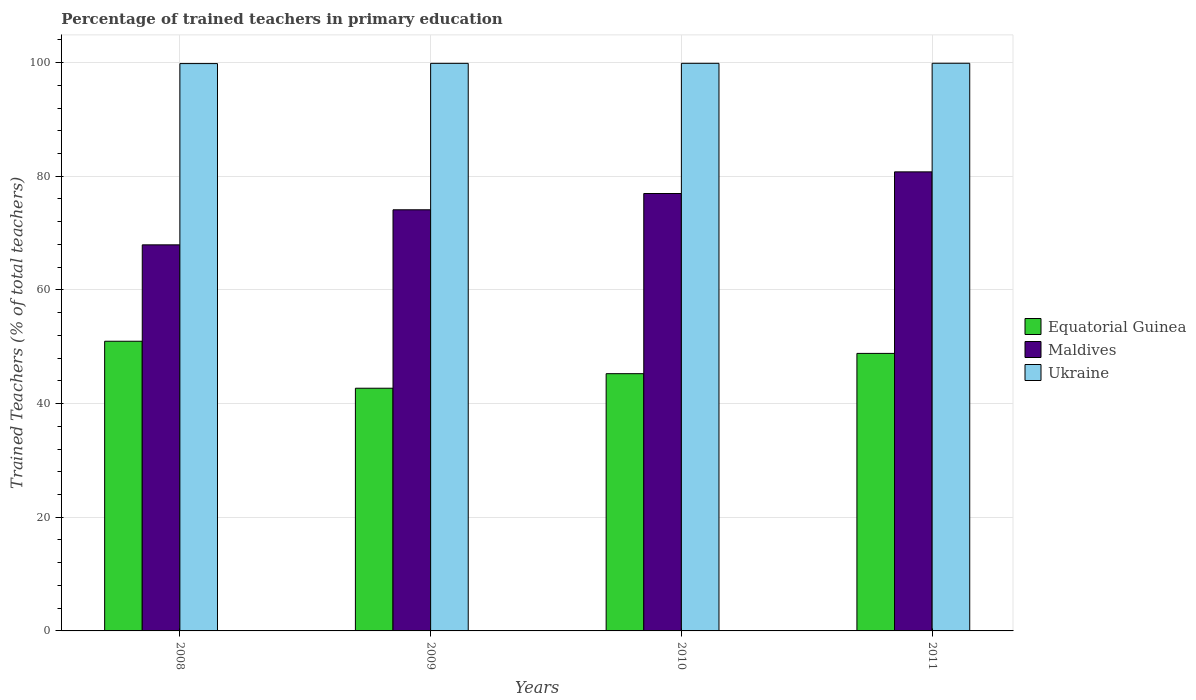How many groups of bars are there?
Offer a very short reply. 4. Are the number of bars per tick equal to the number of legend labels?
Provide a short and direct response. Yes. Are the number of bars on each tick of the X-axis equal?
Provide a succinct answer. Yes. How many bars are there on the 3rd tick from the right?
Ensure brevity in your answer.  3. In how many cases, is the number of bars for a given year not equal to the number of legend labels?
Your answer should be compact. 0. What is the percentage of trained teachers in Ukraine in 2009?
Offer a very short reply. 99.86. Across all years, what is the maximum percentage of trained teachers in Maldives?
Your response must be concise. 80.76. Across all years, what is the minimum percentage of trained teachers in Equatorial Guinea?
Your response must be concise. 42.7. In which year was the percentage of trained teachers in Ukraine minimum?
Provide a succinct answer. 2008. What is the total percentage of trained teachers in Maldives in the graph?
Keep it short and to the point. 299.74. What is the difference between the percentage of trained teachers in Maldives in 2008 and that in 2009?
Your response must be concise. -6.17. What is the difference between the percentage of trained teachers in Ukraine in 2008 and the percentage of trained teachers in Equatorial Guinea in 2010?
Your response must be concise. 54.56. What is the average percentage of trained teachers in Ukraine per year?
Your response must be concise. 99.85. In the year 2010, what is the difference between the percentage of trained teachers in Ukraine and percentage of trained teachers in Maldives?
Make the answer very short. 22.91. What is the ratio of the percentage of trained teachers in Maldives in 2009 to that in 2010?
Provide a succinct answer. 0.96. Is the percentage of trained teachers in Equatorial Guinea in 2008 less than that in 2009?
Your answer should be compact. No. Is the difference between the percentage of trained teachers in Ukraine in 2009 and 2010 greater than the difference between the percentage of trained teachers in Maldives in 2009 and 2010?
Ensure brevity in your answer.  Yes. What is the difference between the highest and the second highest percentage of trained teachers in Maldives?
Your answer should be very brief. 3.81. What is the difference between the highest and the lowest percentage of trained teachers in Equatorial Guinea?
Make the answer very short. 8.27. In how many years, is the percentage of trained teachers in Maldives greater than the average percentage of trained teachers in Maldives taken over all years?
Offer a very short reply. 2. Is the sum of the percentage of trained teachers in Equatorial Guinea in 2008 and 2009 greater than the maximum percentage of trained teachers in Maldives across all years?
Ensure brevity in your answer.  Yes. What does the 3rd bar from the left in 2008 represents?
Offer a very short reply. Ukraine. What does the 3rd bar from the right in 2009 represents?
Keep it short and to the point. Equatorial Guinea. Is it the case that in every year, the sum of the percentage of trained teachers in Ukraine and percentage of trained teachers in Equatorial Guinea is greater than the percentage of trained teachers in Maldives?
Offer a very short reply. Yes. How many bars are there?
Keep it short and to the point. 12. Does the graph contain any zero values?
Give a very brief answer. No. Does the graph contain grids?
Ensure brevity in your answer.  Yes. How many legend labels are there?
Offer a terse response. 3. How are the legend labels stacked?
Offer a terse response. Vertical. What is the title of the graph?
Offer a terse response. Percentage of trained teachers in primary education. What is the label or title of the X-axis?
Your response must be concise. Years. What is the label or title of the Y-axis?
Keep it short and to the point. Trained Teachers (% of total teachers). What is the Trained Teachers (% of total teachers) in Equatorial Guinea in 2008?
Your answer should be very brief. 50.97. What is the Trained Teachers (% of total teachers) in Maldives in 2008?
Your answer should be compact. 67.92. What is the Trained Teachers (% of total teachers) of Ukraine in 2008?
Your response must be concise. 99.82. What is the Trained Teachers (% of total teachers) in Equatorial Guinea in 2009?
Your answer should be very brief. 42.7. What is the Trained Teachers (% of total teachers) in Maldives in 2009?
Your answer should be very brief. 74.09. What is the Trained Teachers (% of total teachers) of Ukraine in 2009?
Make the answer very short. 99.86. What is the Trained Teachers (% of total teachers) of Equatorial Guinea in 2010?
Make the answer very short. 45.26. What is the Trained Teachers (% of total teachers) of Maldives in 2010?
Your answer should be compact. 76.96. What is the Trained Teachers (% of total teachers) in Ukraine in 2010?
Your answer should be compact. 99.86. What is the Trained Teachers (% of total teachers) in Equatorial Guinea in 2011?
Your answer should be very brief. 48.83. What is the Trained Teachers (% of total teachers) of Maldives in 2011?
Ensure brevity in your answer.  80.76. What is the Trained Teachers (% of total teachers) in Ukraine in 2011?
Provide a succinct answer. 99.87. Across all years, what is the maximum Trained Teachers (% of total teachers) in Equatorial Guinea?
Provide a short and direct response. 50.97. Across all years, what is the maximum Trained Teachers (% of total teachers) of Maldives?
Ensure brevity in your answer.  80.76. Across all years, what is the maximum Trained Teachers (% of total teachers) in Ukraine?
Keep it short and to the point. 99.87. Across all years, what is the minimum Trained Teachers (% of total teachers) of Equatorial Guinea?
Your answer should be very brief. 42.7. Across all years, what is the minimum Trained Teachers (% of total teachers) of Maldives?
Offer a very short reply. 67.92. Across all years, what is the minimum Trained Teachers (% of total teachers) of Ukraine?
Provide a short and direct response. 99.82. What is the total Trained Teachers (% of total teachers) of Equatorial Guinea in the graph?
Provide a short and direct response. 187.75. What is the total Trained Teachers (% of total teachers) of Maldives in the graph?
Provide a succinct answer. 299.74. What is the total Trained Teachers (% of total teachers) of Ukraine in the graph?
Provide a succinct answer. 399.41. What is the difference between the Trained Teachers (% of total teachers) of Equatorial Guinea in 2008 and that in 2009?
Your response must be concise. 8.27. What is the difference between the Trained Teachers (% of total teachers) of Maldives in 2008 and that in 2009?
Offer a very short reply. -6.17. What is the difference between the Trained Teachers (% of total teachers) in Ukraine in 2008 and that in 2009?
Provide a short and direct response. -0.04. What is the difference between the Trained Teachers (% of total teachers) in Equatorial Guinea in 2008 and that in 2010?
Offer a terse response. 5.71. What is the difference between the Trained Teachers (% of total teachers) of Maldives in 2008 and that in 2010?
Ensure brevity in your answer.  -9.03. What is the difference between the Trained Teachers (% of total teachers) in Ukraine in 2008 and that in 2010?
Give a very brief answer. -0.05. What is the difference between the Trained Teachers (% of total teachers) in Equatorial Guinea in 2008 and that in 2011?
Keep it short and to the point. 2.14. What is the difference between the Trained Teachers (% of total teachers) of Maldives in 2008 and that in 2011?
Give a very brief answer. -12.84. What is the difference between the Trained Teachers (% of total teachers) of Ukraine in 2008 and that in 2011?
Ensure brevity in your answer.  -0.06. What is the difference between the Trained Teachers (% of total teachers) of Equatorial Guinea in 2009 and that in 2010?
Ensure brevity in your answer.  -2.56. What is the difference between the Trained Teachers (% of total teachers) in Maldives in 2009 and that in 2010?
Provide a succinct answer. -2.87. What is the difference between the Trained Teachers (% of total teachers) of Ukraine in 2009 and that in 2010?
Make the answer very short. -0.01. What is the difference between the Trained Teachers (% of total teachers) in Equatorial Guinea in 2009 and that in 2011?
Offer a very short reply. -6.13. What is the difference between the Trained Teachers (% of total teachers) in Maldives in 2009 and that in 2011?
Provide a succinct answer. -6.67. What is the difference between the Trained Teachers (% of total teachers) of Ukraine in 2009 and that in 2011?
Provide a short and direct response. -0.02. What is the difference between the Trained Teachers (% of total teachers) of Equatorial Guinea in 2010 and that in 2011?
Your answer should be very brief. -3.57. What is the difference between the Trained Teachers (% of total teachers) of Maldives in 2010 and that in 2011?
Ensure brevity in your answer.  -3.81. What is the difference between the Trained Teachers (% of total teachers) of Ukraine in 2010 and that in 2011?
Give a very brief answer. -0.01. What is the difference between the Trained Teachers (% of total teachers) of Equatorial Guinea in 2008 and the Trained Teachers (% of total teachers) of Maldives in 2009?
Offer a terse response. -23.13. What is the difference between the Trained Teachers (% of total teachers) in Equatorial Guinea in 2008 and the Trained Teachers (% of total teachers) in Ukraine in 2009?
Your response must be concise. -48.89. What is the difference between the Trained Teachers (% of total teachers) in Maldives in 2008 and the Trained Teachers (% of total teachers) in Ukraine in 2009?
Ensure brevity in your answer.  -31.93. What is the difference between the Trained Teachers (% of total teachers) in Equatorial Guinea in 2008 and the Trained Teachers (% of total teachers) in Maldives in 2010?
Give a very brief answer. -25.99. What is the difference between the Trained Teachers (% of total teachers) in Equatorial Guinea in 2008 and the Trained Teachers (% of total teachers) in Ukraine in 2010?
Provide a short and direct response. -48.9. What is the difference between the Trained Teachers (% of total teachers) of Maldives in 2008 and the Trained Teachers (% of total teachers) of Ukraine in 2010?
Provide a succinct answer. -31.94. What is the difference between the Trained Teachers (% of total teachers) of Equatorial Guinea in 2008 and the Trained Teachers (% of total teachers) of Maldives in 2011?
Ensure brevity in your answer.  -29.8. What is the difference between the Trained Teachers (% of total teachers) in Equatorial Guinea in 2008 and the Trained Teachers (% of total teachers) in Ukraine in 2011?
Ensure brevity in your answer.  -48.91. What is the difference between the Trained Teachers (% of total teachers) in Maldives in 2008 and the Trained Teachers (% of total teachers) in Ukraine in 2011?
Your answer should be compact. -31.95. What is the difference between the Trained Teachers (% of total teachers) in Equatorial Guinea in 2009 and the Trained Teachers (% of total teachers) in Maldives in 2010?
Ensure brevity in your answer.  -34.26. What is the difference between the Trained Teachers (% of total teachers) in Equatorial Guinea in 2009 and the Trained Teachers (% of total teachers) in Ukraine in 2010?
Your answer should be compact. -57.17. What is the difference between the Trained Teachers (% of total teachers) of Maldives in 2009 and the Trained Teachers (% of total teachers) of Ukraine in 2010?
Provide a short and direct response. -25.77. What is the difference between the Trained Teachers (% of total teachers) in Equatorial Guinea in 2009 and the Trained Teachers (% of total teachers) in Maldives in 2011?
Your answer should be very brief. -38.07. What is the difference between the Trained Teachers (% of total teachers) of Equatorial Guinea in 2009 and the Trained Teachers (% of total teachers) of Ukraine in 2011?
Provide a succinct answer. -57.17. What is the difference between the Trained Teachers (% of total teachers) of Maldives in 2009 and the Trained Teachers (% of total teachers) of Ukraine in 2011?
Make the answer very short. -25.78. What is the difference between the Trained Teachers (% of total teachers) in Equatorial Guinea in 2010 and the Trained Teachers (% of total teachers) in Maldives in 2011?
Ensure brevity in your answer.  -35.51. What is the difference between the Trained Teachers (% of total teachers) in Equatorial Guinea in 2010 and the Trained Teachers (% of total teachers) in Ukraine in 2011?
Keep it short and to the point. -54.62. What is the difference between the Trained Teachers (% of total teachers) of Maldives in 2010 and the Trained Teachers (% of total teachers) of Ukraine in 2011?
Offer a very short reply. -22.92. What is the average Trained Teachers (% of total teachers) in Equatorial Guinea per year?
Offer a very short reply. 46.94. What is the average Trained Teachers (% of total teachers) of Maldives per year?
Make the answer very short. 74.93. What is the average Trained Teachers (% of total teachers) in Ukraine per year?
Make the answer very short. 99.85. In the year 2008, what is the difference between the Trained Teachers (% of total teachers) in Equatorial Guinea and Trained Teachers (% of total teachers) in Maldives?
Ensure brevity in your answer.  -16.96. In the year 2008, what is the difference between the Trained Teachers (% of total teachers) of Equatorial Guinea and Trained Teachers (% of total teachers) of Ukraine?
Your answer should be very brief. -48.85. In the year 2008, what is the difference between the Trained Teachers (% of total teachers) of Maldives and Trained Teachers (% of total teachers) of Ukraine?
Provide a short and direct response. -31.89. In the year 2009, what is the difference between the Trained Teachers (% of total teachers) in Equatorial Guinea and Trained Teachers (% of total teachers) in Maldives?
Keep it short and to the point. -31.39. In the year 2009, what is the difference between the Trained Teachers (% of total teachers) of Equatorial Guinea and Trained Teachers (% of total teachers) of Ukraine?
Your answer should be very brief. -57.16. In the year 2009, what is the difference between the Trained Teachers (% of total teachers) in Maldives and Trained Teachers (% of total teachers) in Ukraine?
Provide a short and direct response. -25.76. In the year 2010, what is the difference between the Trained Teachers (% of total teachers) of Equatorial Guinea and Trained Teachers (% of total teachers) of Maldives?
Ensure brevity in your answer.  -31.7. In the year 2010, what is the difference between the Trained Teachers (% of total teachers) of Equatorial Guinea and Trained Teachers (% of total teachers) of Ukraine?
Your answer should be very brief. -54.61. In the year 2010, what is the difference between the Trained Teachers (% of total teachers) in Maldives and Trained Teachers (% of total teachers) in Ukraine?
Your answer should be compact. -22.91. In the year 2011, what is the difference between the Trained Teachers (% of total teachers) of Equatorial Guinea and Trained Teachers (% of total teachers) of Maldives?
Your response must be concise. -31.94. In the year 2011, what is the difference between the Trained Teachers (% of total teachers) in Equatorial Guinea and Trained Teachers (% of total teachers) in Ukraine?
Keep it short and to the point. -51.05. In the year 2011, what is the difference between the Trained Teachers (% of total teachers) of Maldives and Trained Teachers (% of total teachers) of Ukraine?
Your response must be concise. -19.11. What is the ratio of the Trained Teachers (% of total teachers) in Equatorial Guinea in 2008 to that in 2009?
Your answer should be compact. 1.19. What is the ratio of the Trained Teachers (% of total teachers) of Maldives in 2008 to that in 2009?
Give a very brief answer. 0.92. What is the ratio of the Trained Teachers (% of total teachers) in Equatorial Guinea in 2008 to that in 2010?
Your answer should be very brief. 1.13. What is the ratio of the Trained Teachers (% of total teachers) in Maldives in 2008 to that in 2010?
Your response must be concise. 0.88. What is the ratio of the Trained Teachers (% of total teachers) of Ukraine in 2008 to that in 2010?
Your answer should be compact. 1. What is the ratio of the Trained Teachers (% of total teachers) in Equatorial Guinea in 2008 to that in 2011?
Your answer should be compact. 1.04. What is the ratio of the Trained Teachers (% of total teachers) in Maldives in 2008 to that in 2011?
Provide a succinct answer. 0.84. What is the ratio of the Trained Teachers (% of total teachers) of Equatorial Guinea in 2009 to that in 2010?
Offer a very short reply. 0.94. What is the ratio of the Trained Teachers (% of total teachers) in Maldives in 2009 to that in 2010?
Offer a very short reply. 0.96. What is the ratio of the Trained Teachers (% of total teachers) in Equatorial Guinea in 2009 to that in 2011?
Make the answer very short. 0.87. What is the ratio of the Trained Teachers (% of total teachers) of Maldives in 2009 to that in 2011?
Give a very brief answer. 0.92. What is the ratio of the Trained Teachers (% of total teachers) of Ukraine in 2009 to that in 2011?
Offer a terse response. 1. What is the ratio of the Trained Teachers (% of total teachers) of Equatorial Guinea in 2010 to that in 2011?
Provide a succinct answer. 0.93. What is the ratio of the Trained Teachers (% of total teachers) of Maldives in 2010 to that in 2011?
Your answer should be very brief. 0.95. What is the difference between the highest and the second highest Trained Teachers (% of total teachers) in Equatorial Guinea?
Your response must be concise. 2.14. What is the difference between the highest and the second highest Trained Teachers (% of total teachers) of Maldives?
Your answer should be compact. 3.81. What is the difference between the highest and the second highest Trained Teachers (% of total teachers) of Ukraine?
Provide a succinct answer. 0.01. What is the difference between the highest and the lowest Trained Teachers (% of total teachers) of Equatorial Guinea?
Keep it short and to the point. 8.27. What is the difference between the highest and the lowest Trained Teachers (% of total teachers) in Maldives?
Keep it short and to the point. 12.84. What is the difference between the highest and the lowest Trained Teachers (% of total teachers) of Ukraine?
Your response must be concise. 0.06. 